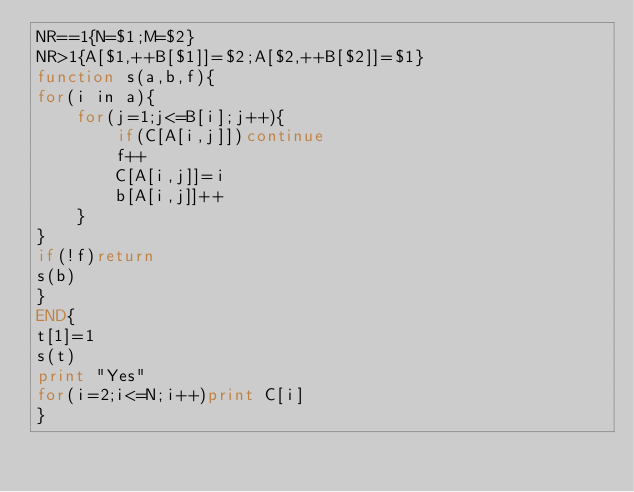Convert code to text. <code><loc_0><loc_0><loc_500><loc_500><_Awk_>NR==1{N=$1;M=$2}
NR>1{A[$1,++B[$1]]=$2;A[$2,++B[$2]]=$1}
function s(a,b,f){
for(i in a){
    for(j=1;j<=B[i];j++){
        if(C[A[i,j]])continue
        f++
        C[A[i,j]]=i
        b[A[i,j]]++
    }
}
if(!f)return
s(b)
}
END{
t[1]=1
s(t)
print "Yes"
for(i=2;i<=N;i++)print C[i]
}</code> 